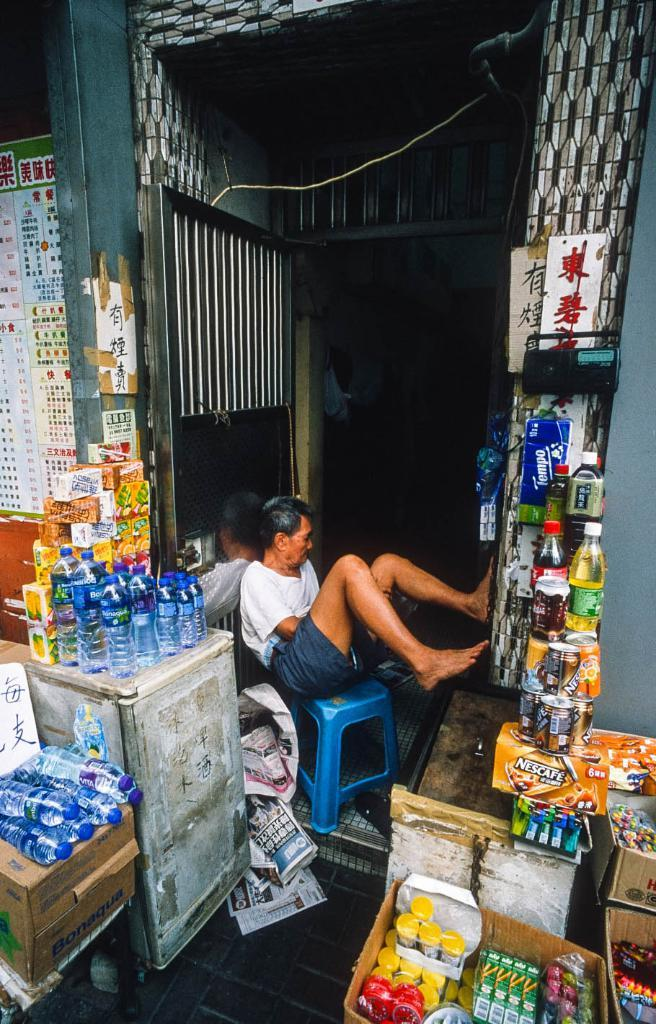<image>
Render a clear and concise summary of the photo. A man sits in the doorway among products such as Nescafe and Tempo. 